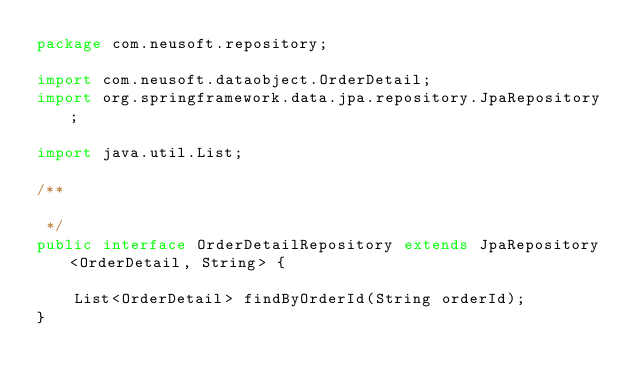Convert code to text. <code><loc_0><loc_0><loc_500><loc_500><_Java_>package com.neusoft.repository;

import com.neusoft.dataobject.OrderDetail;
import org.springframework.data.jpa.repository.JpaRepository;

import java.util.List;

/**

 */
public interface OrderDetailRepository extends JpaRepository<OrderDetail, String> {

    List<OrderDetail> findByOrderId(String orderId);
}
</code> 